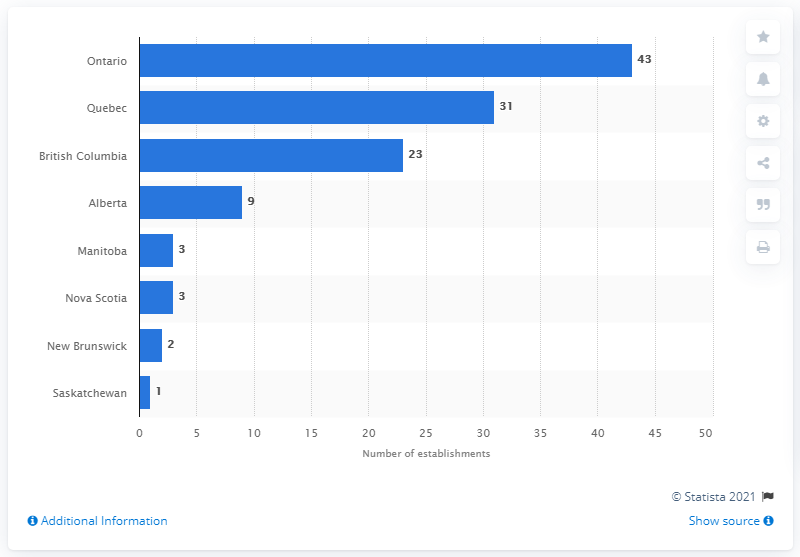Give some essential details in this illustration. In December 2020, there were 43 ice cream and frozen dessert manufacturing establishments in Ontario. 